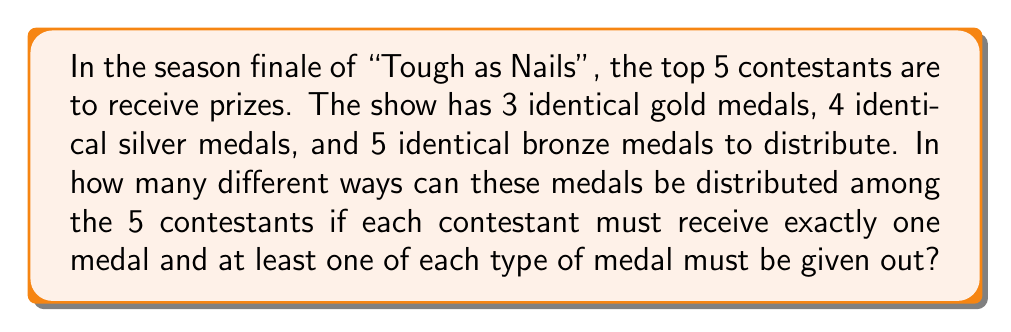Could you help me with this problem? Let's approach this step-by-step:

1) We need to distribute 12 medals (3 gold, 4 silver, 5 bronze) among 5 contestants, with each contestant getting exactly one medal.

2) We must ensure at least one of each type is given out. So, let's first assign one gold, one silver, and one bronze medal:

   $$\binom{5}{1} \cdot \binom{4}{1} \cdot \binom{3}{1} = 60$$

3) Now we have 2 gold, 3 silver, and 4 bronze medals left to distribute among the remaining 2 contestants.

4) This is a classic stars and bars problem. We can represent it as:

   $$\binom{2+3-1}{3-1} \cdot \binom{2+2-1}{2-1} \cdot \binom{2+4-1}{4-1}$$

   Where each term represents the ways to distribute the remaining gold, silver, and bronze medals respectively.

5) Calculating:

   $$\binom{4}{2} \cdot \binom{3}{1} \cdot \binom{5}{3} = 6 \cdot 3 \cdot 10 = 180$$

6) By the multiplication principle, the total number of ways is:

   $$60 \cdot 180 = 10,800$$

Therefore, there are 10,800 different ways to distribute the medals.
Answer: 10,800 